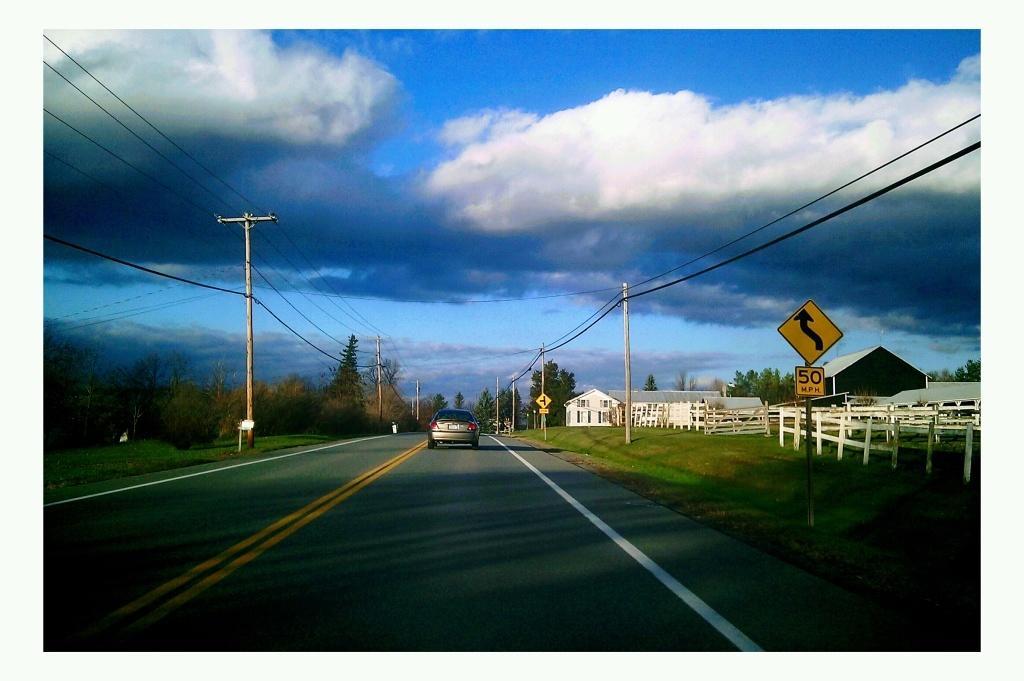Please provide a concise description of this image. In this picture we can see a vehicle on the road. On the left side of the vehicle there are trees and electric poles with wires. On the right side of the vehicle there is the wooden fence, houses, grass, poles with sign boards. Behind the houses there is the sky. 